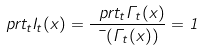<formula> <loc_0><loc_0><loc_500><loc_500>\ p r t _ { t } I _ { t } ( x ) = \frac { \ p r t _ { t } \Gamma _ { t } ( x ) } { \mu ( \Gamma _ { t } ( x ) ) } = 1</formula> 